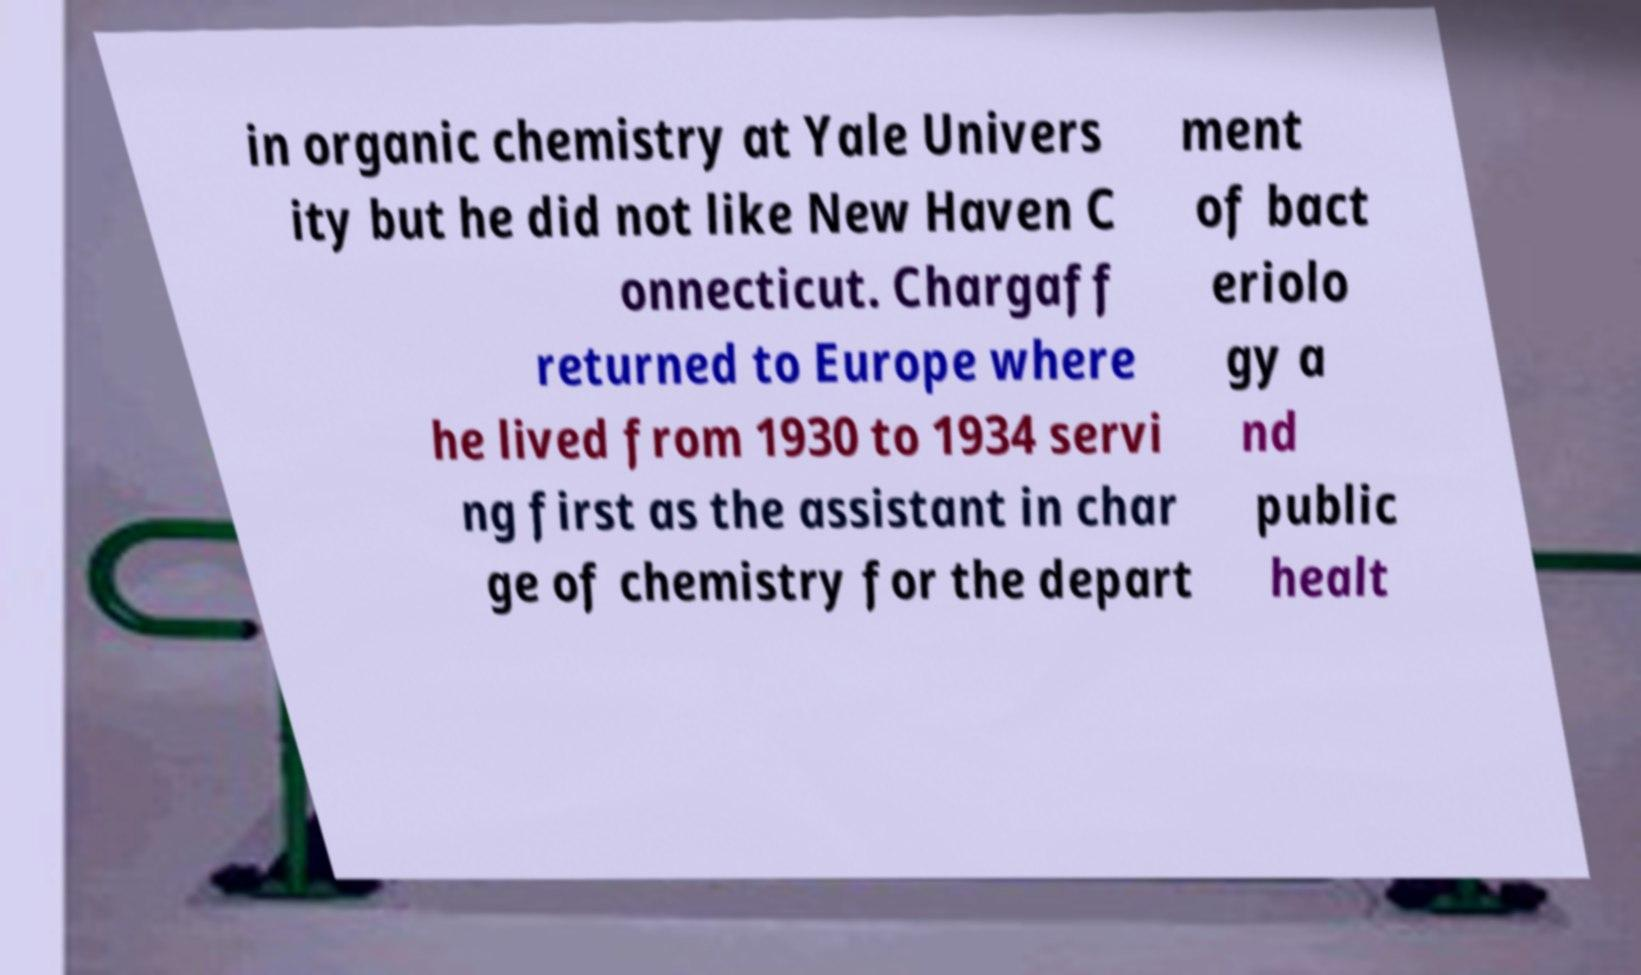Could you assist in decoding the text presented in this image and type it out clearly? in organic chemistry at Yale Univers ity but he did not like New Haven C onnecticut. Chargaff returned to Europe where he lived from 1930 to 1934 servi ng first as the assistant in char ge of chemistry for the depart ment of bact eriolo gy a nd public healt 